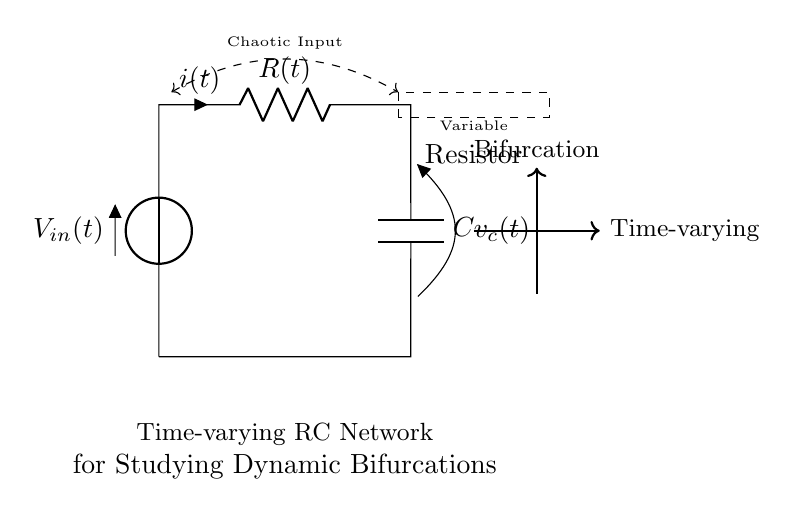What type of components are present in this circuit? The circuit contains a voltage source, a variable resistor, and a capacitor, which are standard components in RC circuits.
Answer: voltage source, variable resistor, capacitor What does the variable resistor represent in this circuit? The variable resistor signifies that its resistance can change over time, which is crucial for the dynamics being studied in bistability and bifurcations.
Answer: time-varying resistance What is denoted by v_c(t) in the circuit? v_c(t) represents the voltage across the capacitor at time t, indicating the state of the charge stored in the capacitor within this time-varying RC network.
Answer: voltage across the capacitor How does the input voltage influence the circuit behavior? The input voltage V_in(t) affects the charging and discharging cycles of the capacitor, which in turn influences the behavior of the current and voltage across the components, leading to dynamic changes and potentially bifurcations.
Answer: influences charging and discharging Why is the concept of chaos important in this RC network? The investigation of chaotic behavior is significant because it can reveal how small changes in input can lead to drastic changes in the output, showcasing the sensitivity and complex dynamics within the circuit at bifurcation points.
Answer: reveals sensitivity to input changes What does the term 'dynamic bifurcations' imply in this context? Dynamic bifurcations refer to the qualitative changes in the system's behavior as parameters, such as resistance or input voltage, fluctuate, causing the circuit to operate in different regimes of stability or chaos.
Answer: qualitative changes in behavior What would happen if the variable resistor is set to a constant value? If the variable resistor is constant, the circuit would behave like a standard RC circuit without time-varying dynamics, resulting in predictable and stable behavior in contrast to the intended study of bifurcations.
Answer: behaves like a standard RC circuit 